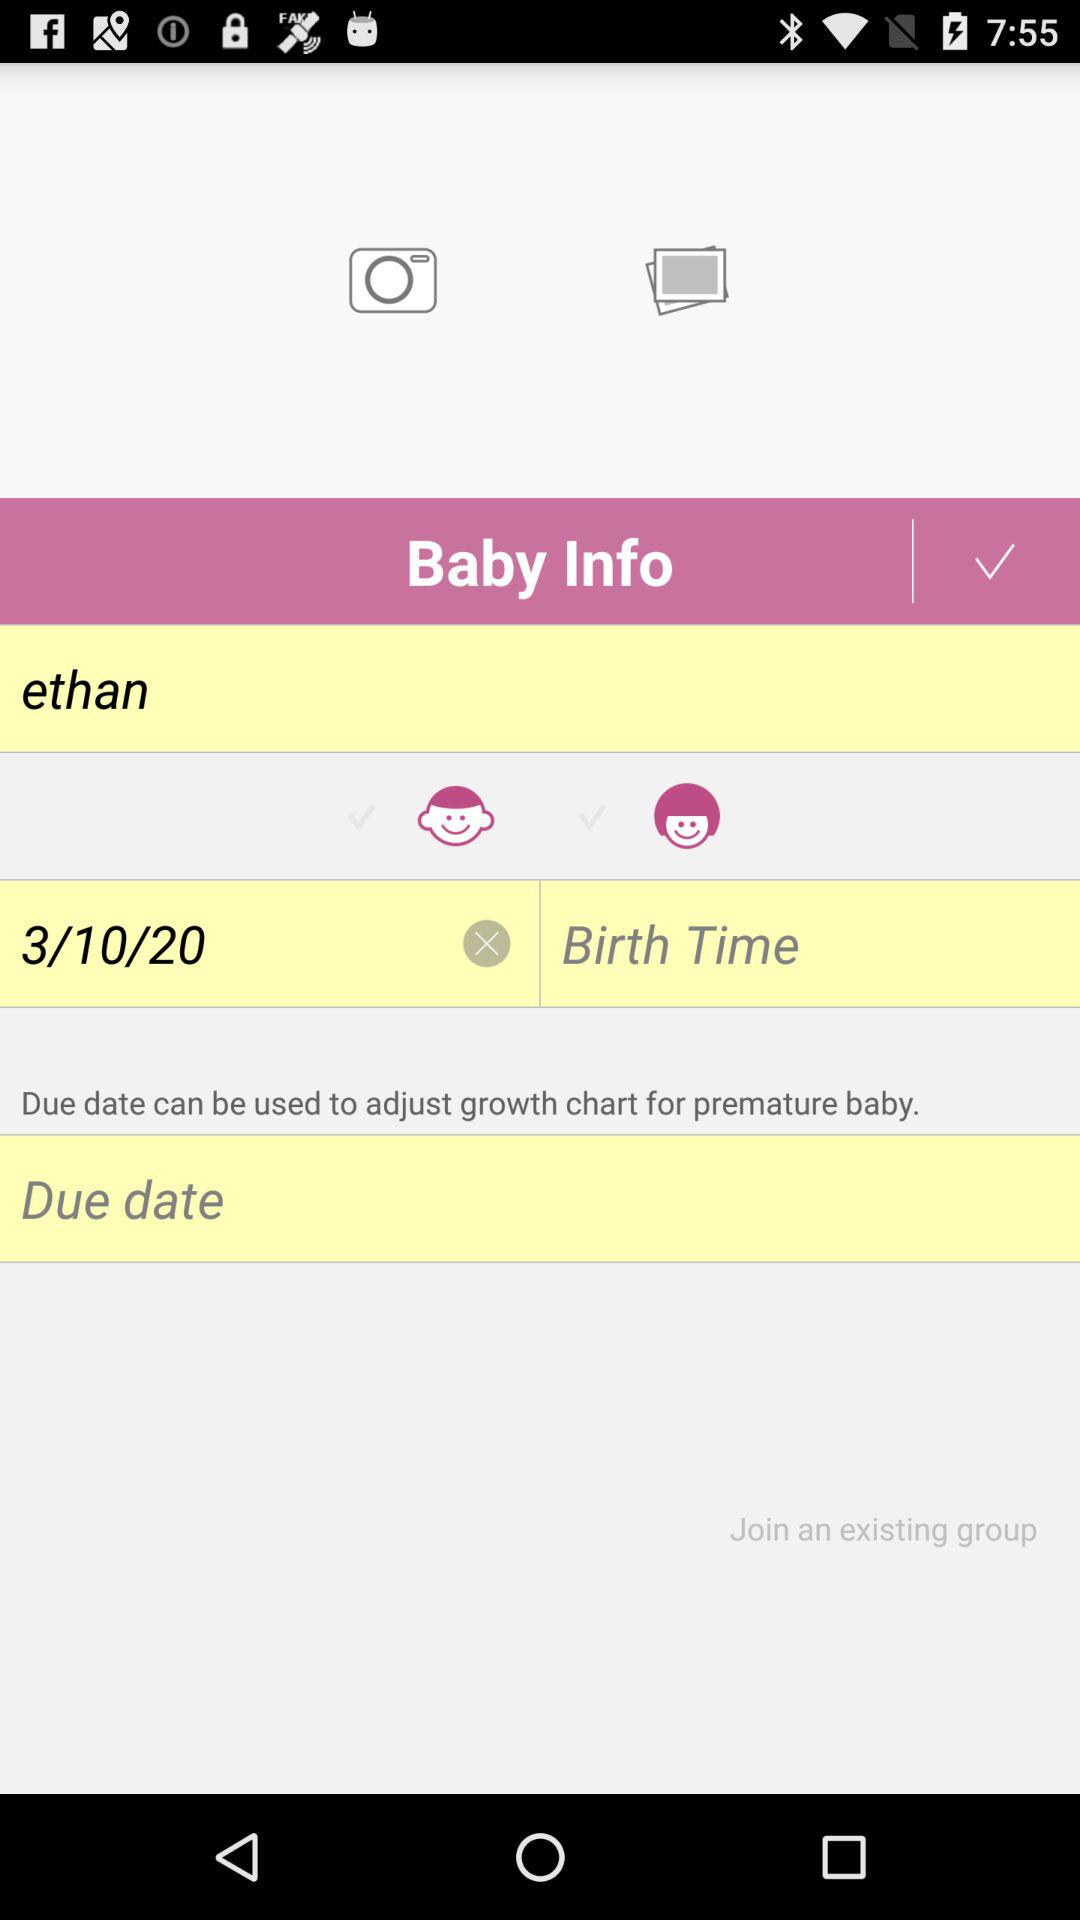What is the birth time?
When the provided information is insufficient, respond with <no answer>. <no answer> 